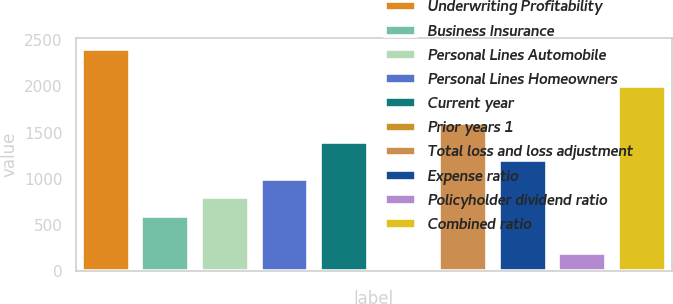Convert chart. <chart><loc_0><loc_0><loc_500><loc_500><bar_chart><fcel>Underwriting Profitability<fcel>Business Insurance<fcel>Personal Lines Automobile<fcel>Personal Lines Homeowners<fcel>Current year<fcel>Prior years 1<fcel>Total loss and loss adjustment<fcel>Expense ratio<fcel>Policyholder dividend ratio<fcel>Combined ratio<nl><fcel>2404.78<fcel>601.27<fcel>801.66<fcel>1002.05<fcel>1402.83<fcel>0.1<fcel>1603.22<fcel>1202.44<fcel>200.49<fcel>2004<nl></chart> 